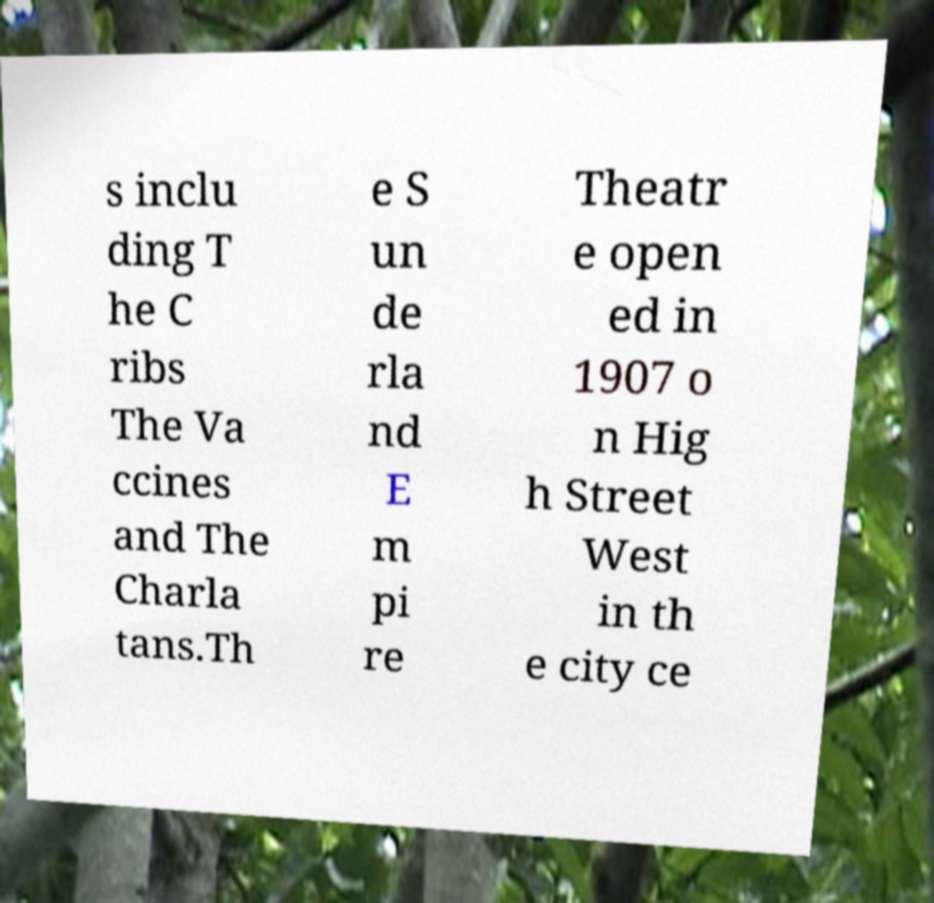For documentation purposes, I need the text within this image transcribed. Could you provide that? s inclu ding T he C ribs The Va ccines and The Charla tans.Th e S un de rla nd E m pi re Theatr e open ed in 1907 o n Hig h Street West in th e city ce 